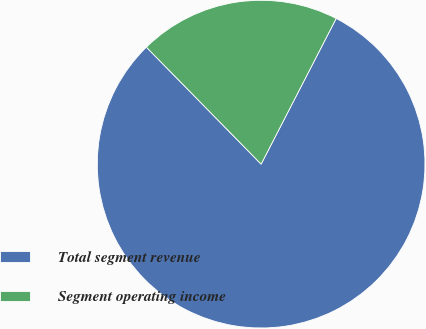<chart> <loc_0><loc_0><loc_500><loc_500><pie_chart><fcel>Total segment revenue<fcel>Segment operating income<nl><fcel>80.08%<fcel>19.92%<nl></chart> 